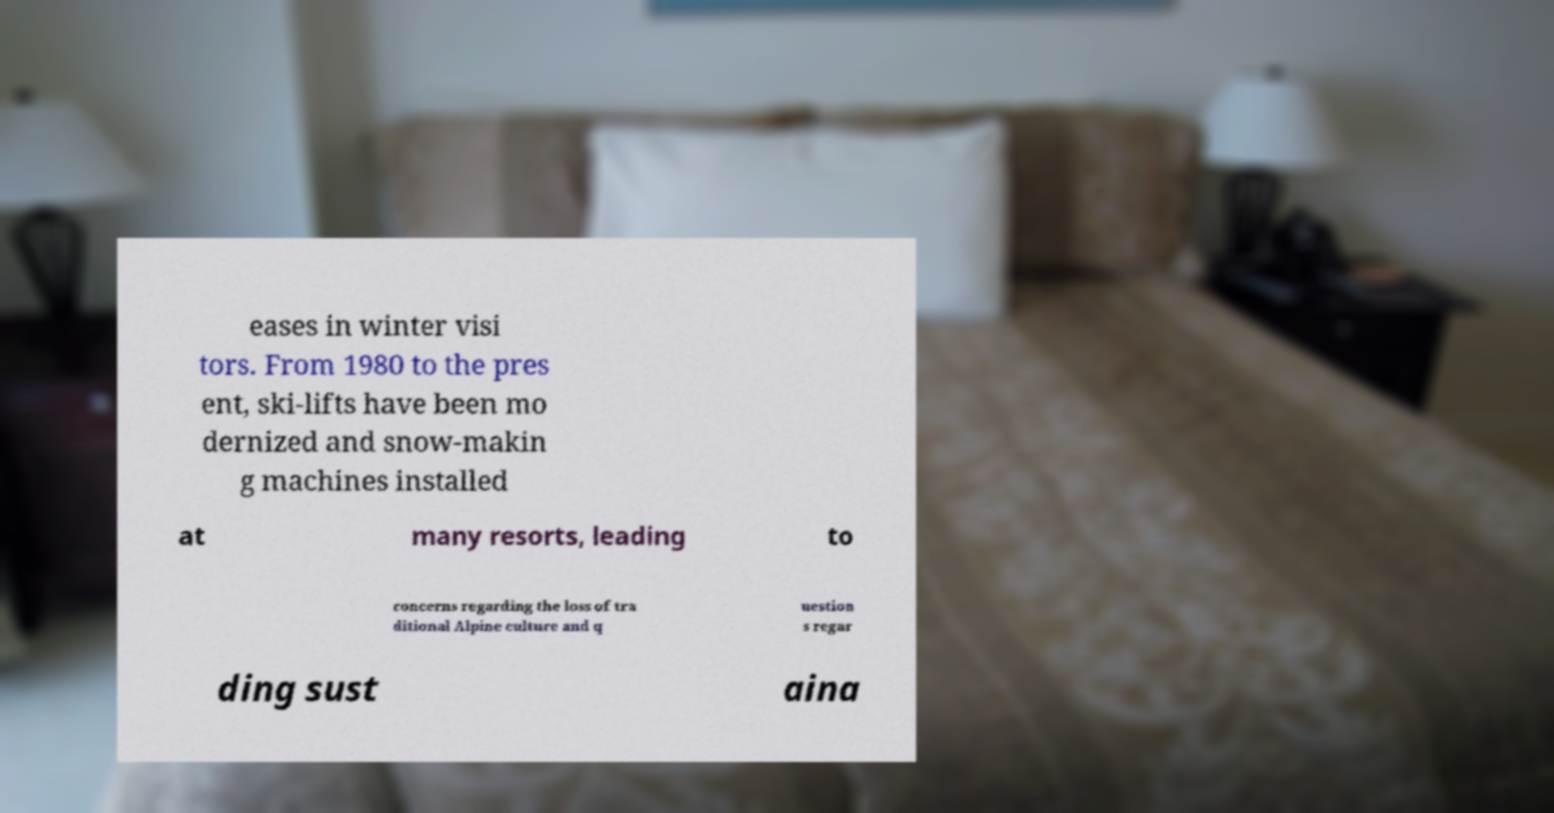I need the written content from this picture converted into text. Can you do that? eases in winter visi tors. From 1980 to the pres ent, ski-lifts have been mo dernized and snow-makin g machines installed at many resorts, leading to concerns regarding the loss of tra ditional Alpine culture and q uestion s regar ding sust aina 